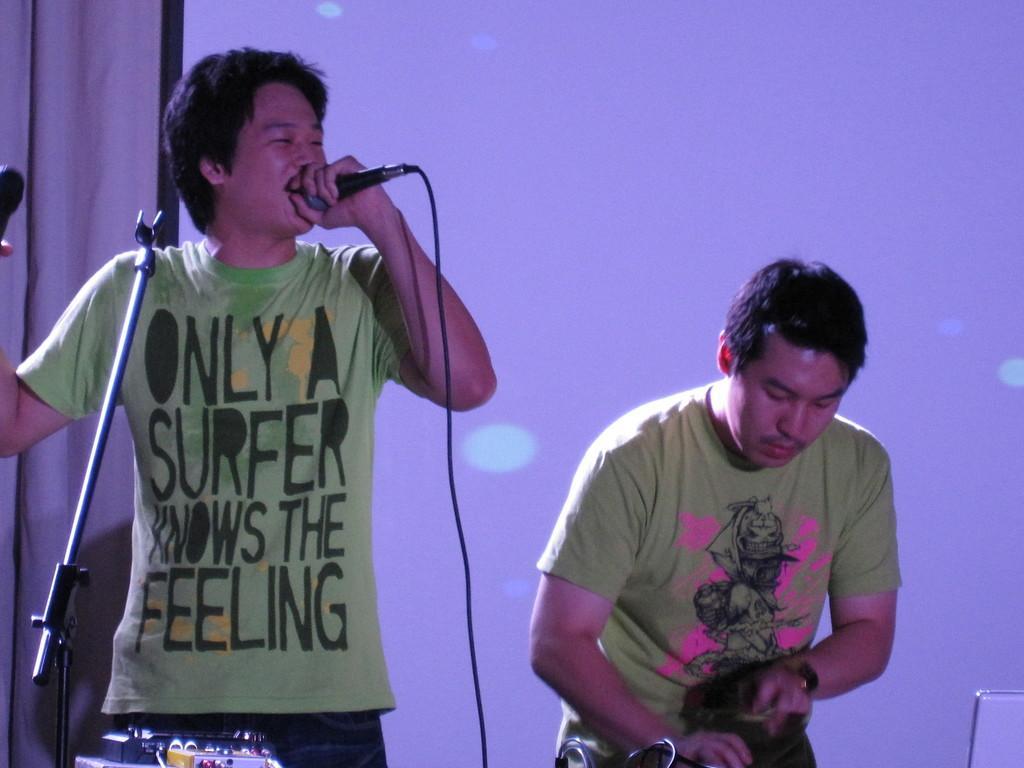Describe this image in one or two sentences. The image is inside the room. In the image there are two men's on left side there is a man standing and he he is also holding a microphone, on right side we can see another person standing. In background we can see a screen and a curtain. 